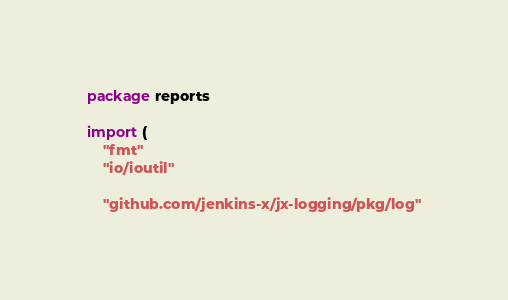Convert code to text. <code><loc_0><loc_0><loc_500><loc_500><_Go_>package reports

import (
	"fmt"
	"io/ioutil"

	"github.com/jenkins-x/jx-logging/pkg/log"</code> 